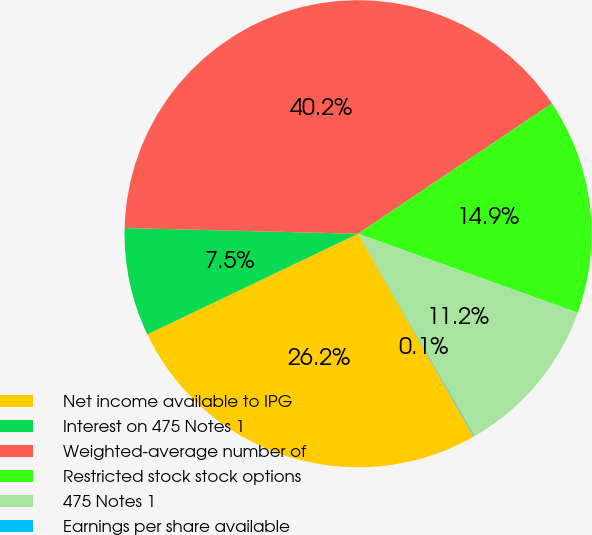Convert chart. <chart><loc_0><loc_0><loc_500><loc_500><pie_chart><fcel>Net income available to IPG<fcel>Interest on 475 Notes 1<fcel>Weighted-average number of<fcel>Restricted stock stock options<fcel>475 Notes 1<fcel>Earnings per share available<nl><fcel>26.16%<fcel>7.48%<fcel>40.19%<fcel>14.91%<fcel>11.2%<fcel>0.05%<nl></chart> 